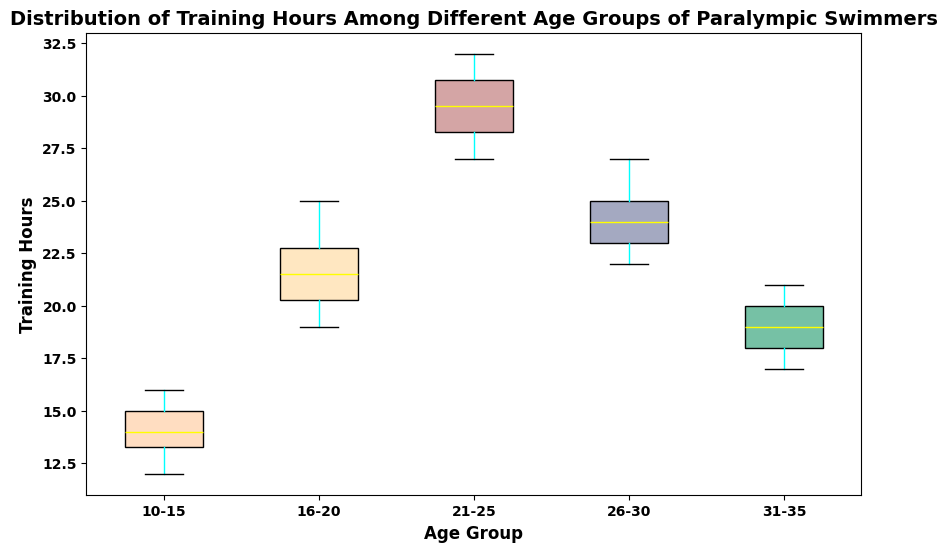What's the median training hours for the 16-20 age group? To find the median, we list the training hours of 16-20 age group in ascending order: [19, 20, 20, 21, 21, 22, 22, 23, 24, 25] and pick the middle value(s). Since there are 10 data points, the median is the average of the 5th and 6th values, (21 + 22) / 2 = 21.5.
Answer: 21.5 Which age group has the highest median training hours? By examining the box plot, we can see that the median line inside each box indicates the median training hours. The 21-25 age group's median line is the highest among all groups.
Answer: 21-25 What is the range of training hours for the 10-15 age group? The range is the difference between the maximum and minimum values within the whiskers (the ends of the plot for that group). For the 10-15 age group, the lowest value is 12, and the highest is 16. So the range is 16 - 12 = 4.
Answer: 4 Which age group has the longest interquartile range (IQR)? The IQR is represented by the box length, covering the middle 50% of the data. The 21-25 age group has the longest box, indicating the widest IQR among all groups.
Answer: 21-25 Compare the spread of training hours for the 26-30 and 31-35 age groups. Which one is more spread out? Spread can be measured by looking at the distance between the whiskers (range) and the length of the box (IQR). The 26-30 age group has a wider range and longer IQR, indicating more spread out data compared to the 31-35 age group.
Answer: 26-30 Which age group has the lowest minimum training hour? The minimum value can be seen at the bottom of the whiskers. The 10-15 age group has the lowest minimum training hours.
Answer: 10-15 For the 21-25 age group, how many training hours fall between the first quartile (Q1) and the median? The first quartile (Q1) marks the 25th percentile, and the median marks the 50th percentile. We need to identify how many training hours fall in this range. List the sorted values and find the ones between Q1 and the median. For 21-25 age group Q1 is 28 and the median is 29.5. The values are 28, 28, 29, 29, thus 4 data points fall between Q1 and median.
Answer: 4 Compare the median training hours for the 10-15 and 26-30 age groups. Which group invests more time in training? The median for 10-15 age group is 14, and for 26-30 age group is 24. Therefore, the 26-30 age group invests more time in training.
Answer: 26-30 Which age group has the most training hours variation (i.e., variance)? Variance can be visually approximated by looking at the spread of the data points (range and IQR). The 21-25 age group appears to have the widest range and IQR, suggesting the highest variation.
Answer: 21-25 